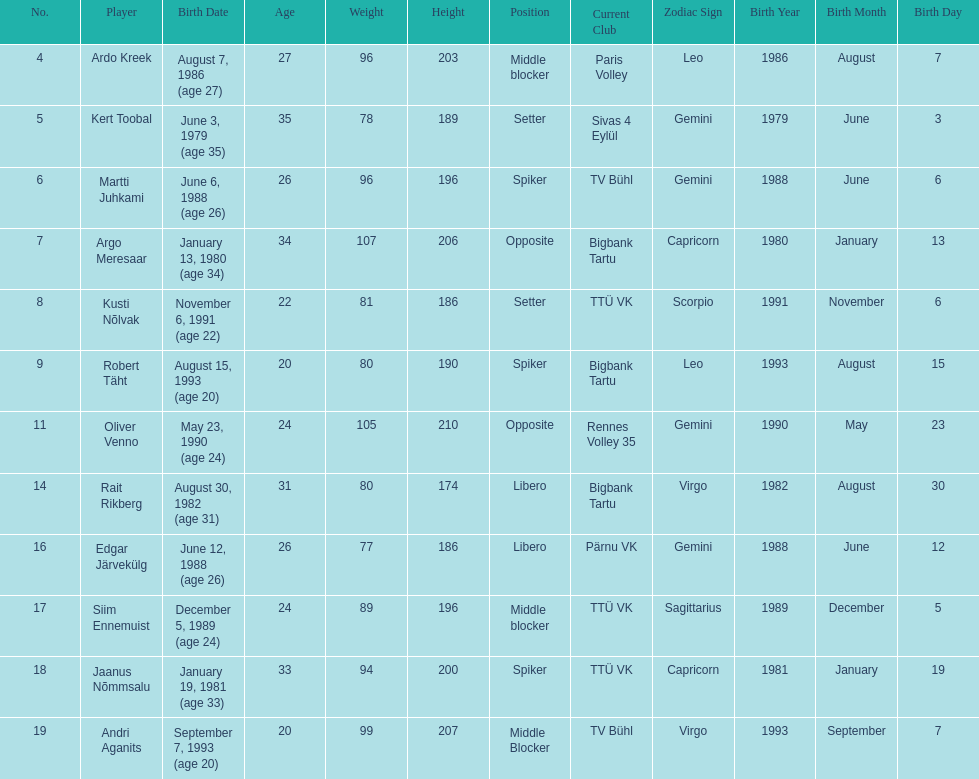How many players are middle blockers? 3. 